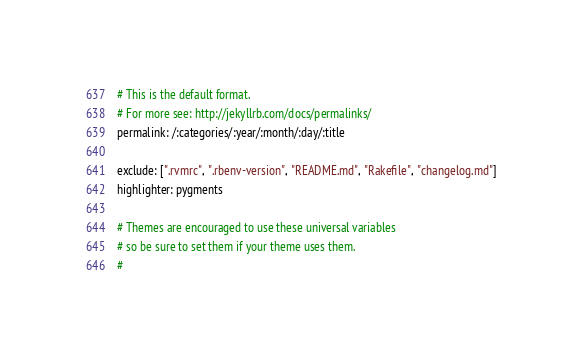<code> <loc_0><loc_0><loc_500><loc_500><_YAML_># This is the default format. 
# For more see: http://jekyllrb.com/docs/permalinks/
permalink: /:categories/:year/:month/:day/:title 

exclude: [".rvmrc", ".rbenv-version", "README.md", "Rakefile", "changelog.md"]
highlighter: pygments

# Themes are encouraged to use these universal variables 
# so be sure to set them if your theme uses them.
#</code> 